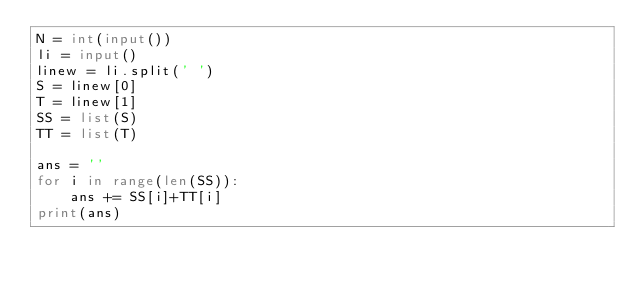<code> <loc_0><loc_0><loc_500><loc_500><_Python_>N = int(input())
li = input()
linew = li.split(' ')
S = linew[0]
T = linew[1]
SS = list(S)
TT = list(T)

ans = ''
for i in range(len(SS)):
    ans += SS[i]+TT[i]
print(ans)</code> 